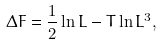Convert formula to latex. <formula><loc_0><loc_0><loc_500><loc_500>\Delta F = \frac { 1 } { 2 } \ln L - T \ln L ^ { 3 } ,</formula> 